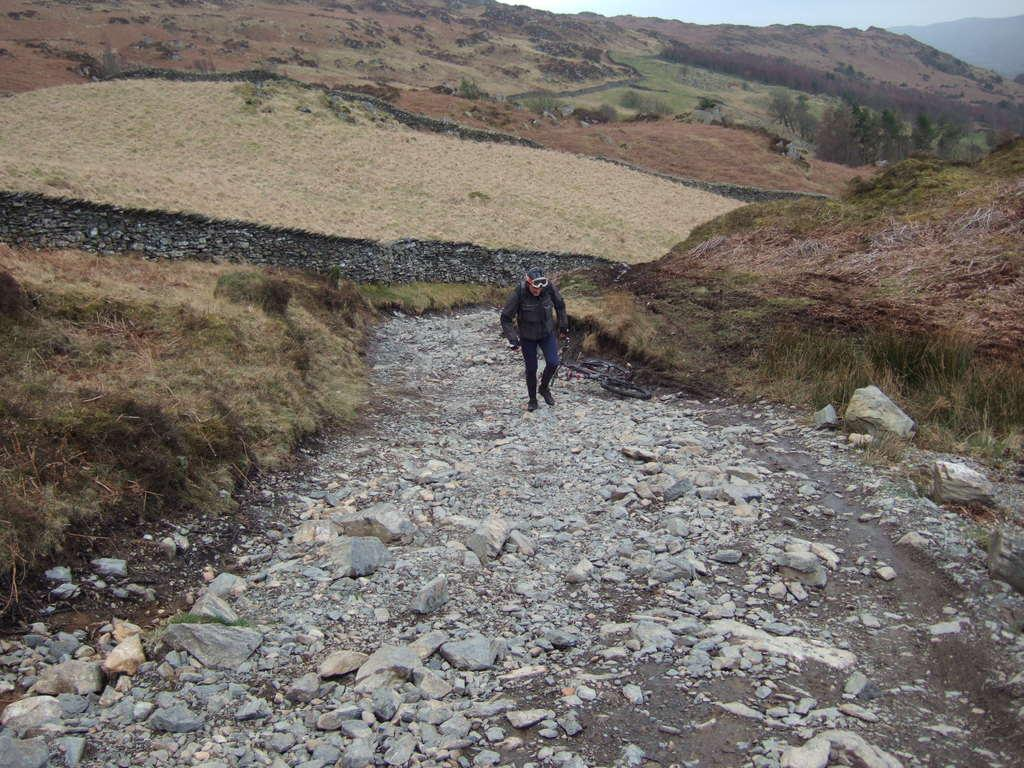What is the primary subject of the image? There is a person standing in the image. What is the person standing on? The person is standing on stones, grass, and the ground. What type of terrain is visible in the image? Hills are visible in the image. What part of the natural environment is visible in the image? The sky is visible in the image. What flavor of toothpaste does the person use in the image? There is no toothpaste or toothbrush present in the image, so it is not possible to determine the flavor of toothpaste the person uses. 